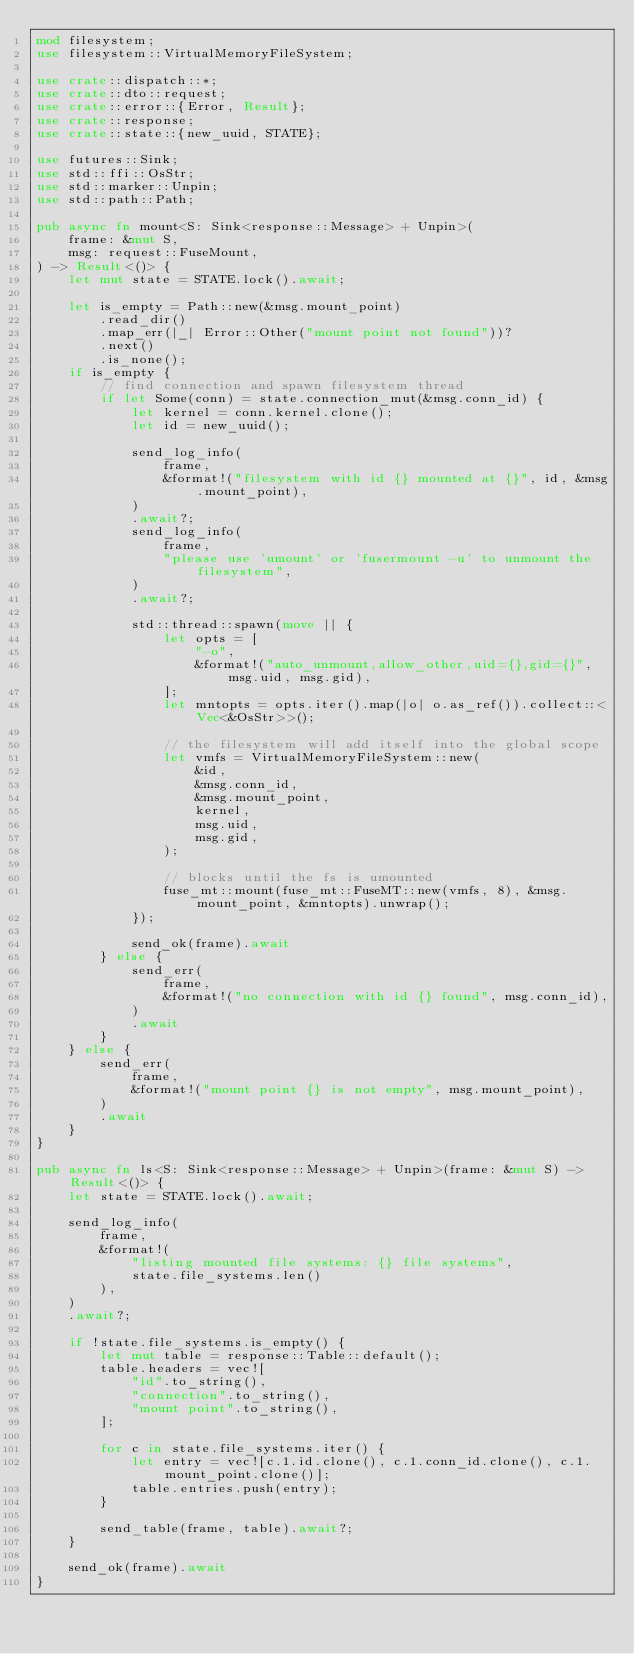Convert code to text. <code><loc_0><loc_0><loc_500><loc_500><_Rust_>mod filesystem;
use filesystem::VirtualMemoryFileSystem;

use crate::dispatch::*;
use crate::dto::request;
use crate::error::{Error, Result};
use crate::response;
use crate::state::{new_uuid, STATE};

use futures::Sink;
use std::ffi::OsStr;
use std::marker::Unpin;
use std::path::Path;

pub async fn mount<S: Sink<response::Message> + Unpin>(
    frame: &mut S,
    msg: request::FuseMount,
) -> Result<()> {
    let mut state = STATE.lock().await;

    let is_empty = Path::new(&msg.mount_point)
        .read_dir()
        .map_err(|_| Error::Other("mount point not found"))?
        .next()
        .is_none();
    if is_empty {
        // find connection and spawn filesystem thread
        if let Some(conn) = state.connection_mut(&msg.conn_id) {
            let kernel = conn.kernel.clone();
            let id = new_uuid();

            send_log_info(
                frame,
                &format!("filesystem with id {} mounted at {}", id, &msg.mount_point),
            )
            .await?;
            send_log_info(
                frame,
                "please use 'umount' or 'fusermount -u' to unmount the filesystem",
            )
            .await?;

            std::thread::spawn(move || {
                let opts = [
                    "-o",
                    &format!("auto_unmount,allow_other,uid={},gid={}", msg.uid, msg.gid),
                ];
                let mntopts = opts.iter().map(|o| o.as_ref()).collect::<Vec<&OsStr>>();

                // the filesystem will add itself into the global scope
                let vmfs = VirtualMemoryFileSystem::new(
                    &id,
                    &msg.conn_id,
                    &msg.mount_point,
                    kernel,
                    msg.uid,
                    msg.gid,
                );

                // blocks until the fs is umounted
                fuse_mt::mount(fuse_mt::FuseMT::new(vmfs, 8), &msg.mount_point, &mntopts).unwrap();
            });

            send_ok(frame).await
        } else {
            send_err(
                frame,
                &format!("no connection with id {} found", msg.conn_id),
            )
            .await
        }
    } else {
        send_err(
            frame,
            &format!("mount point {} is not empty", msg.mount_point),
        )
        .await
    }
}

pub async fn ls<S: Sink<response::Message> + Unpin>(frame: &mut S) -> Result<()> {
    let state = STATE.lock().await;

    send_log_info(
        frame,
        &format!(
            "listing mounted file systems: {} file systems",
            state.file_systems.len()
        ),
    )
    .await?;

    if !state.file_systems.is_empty() {
        let mut table = response::Table::default();
        table.headers = vec![
            "id".to_string(),
            "connection".to_string(),
            "mount point".to_string(),
        ];

        for c in state.file_systems.iter() {
            let entry = vec![c.1.id.clone(), c.1.conn_id.clone(), c.1.mount_point.clone()];
            table.entries.push(entry);
        }

        send_table(frame, table).await?;
    }

    send_ok(frame).await
}
</code> 